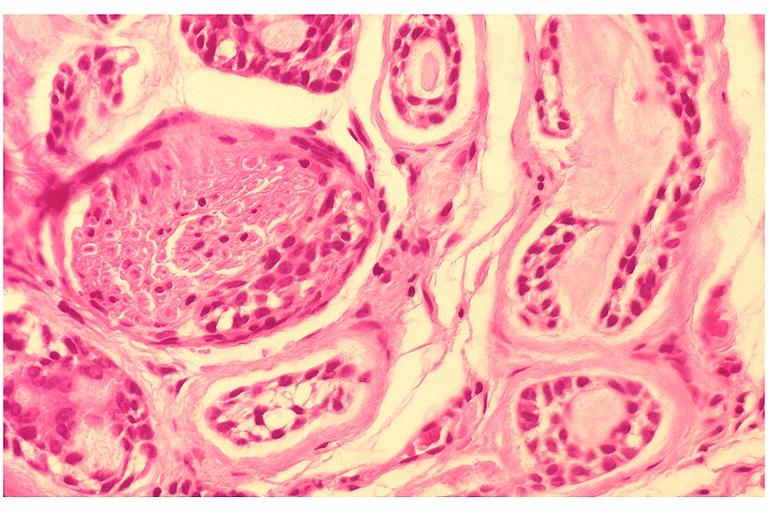s schwannoma present?
Answer the question using a single word or phrase. No 